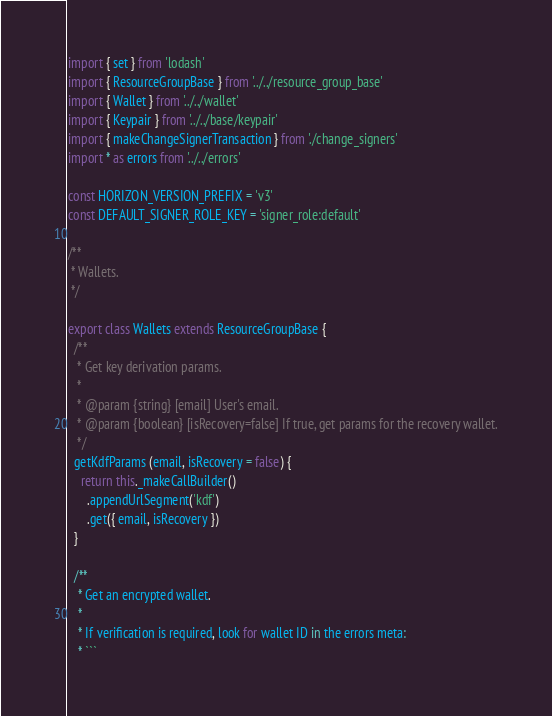Convert code to text. <code><loc_0><loc_0><loc_500><loc_500><_JavaScript_>import { set } from 'lodash'
import { ResourceGroupBase } from '../../resource_group_base'
import { Wallet } from '../../wallet'
import { Keypair } from '../../base/keypair'
import { makeChangeSignerTransaction } from './change_signers'
import * as errors from '../../errors'

const HORIZON_VERSION_PREFIX = 'v3'
const DEFAULT_SIGNER_ROLE_KEY = 'signer_role:default'

/**
 * Wallets.
 */

export class Wallets extends ResourceGroupBase {
  /**
   * Get key derivation params.
   *
   * @param {string} [email] User's email.
   * @param {boolean} [isRecovery=false] If true, get params for the recovery wallet.
   */
  getKdfParams (email, isRecovery = false) {
    return this._makeCallBuilder()
      .appendUrlSegment('kdf')
      .get({ email, isRecovery })
  }

  /**
   * Get an encrypted wallet.
   *
   * If verification is required, look for wallet ID in the errors meta:
   * ```</code> 